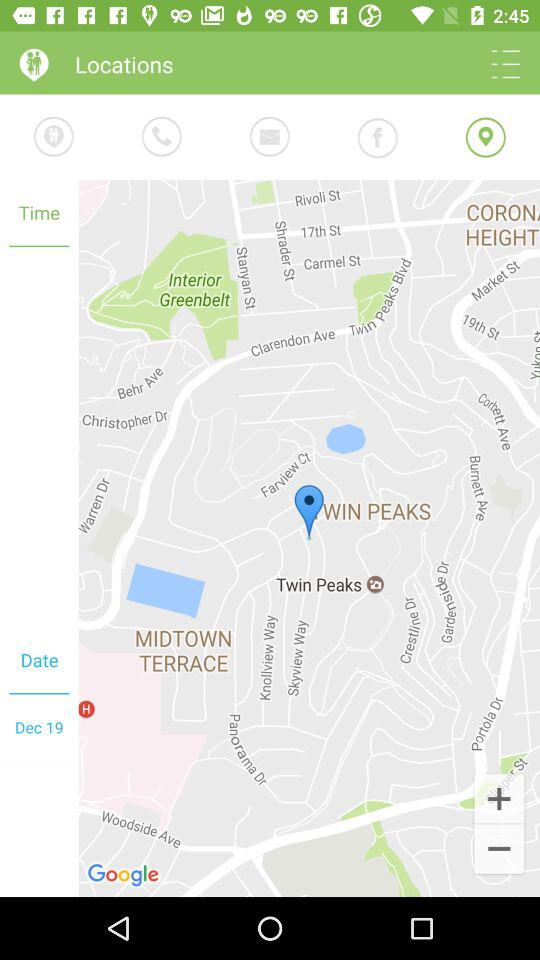What is the mentioned date? The mentioned date is December 19. 